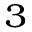Convert formula to latex. <formula><loc_0><loc_0><loc_500><loc_500>_ { 3 }</formula> 